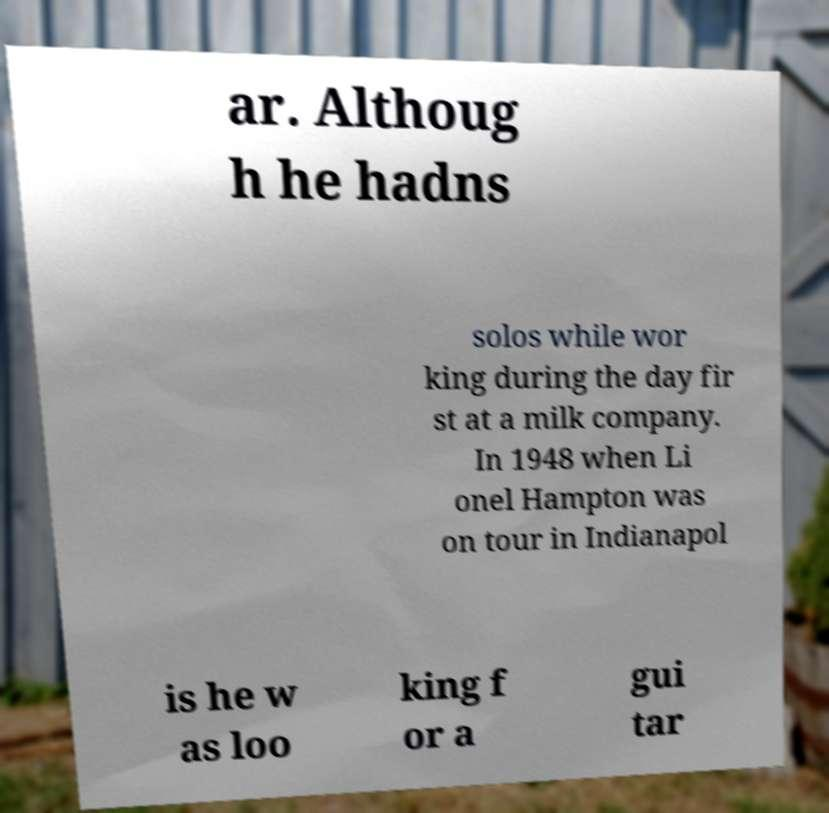Please read and relay the text visible in this image. What does it say? ar. Althoug h he hadns solos while wor king during the day fir st at a milk company. In 1948 when Li onel Hampton was on tour in Indianapol is he w as loo king f or a gui tar 